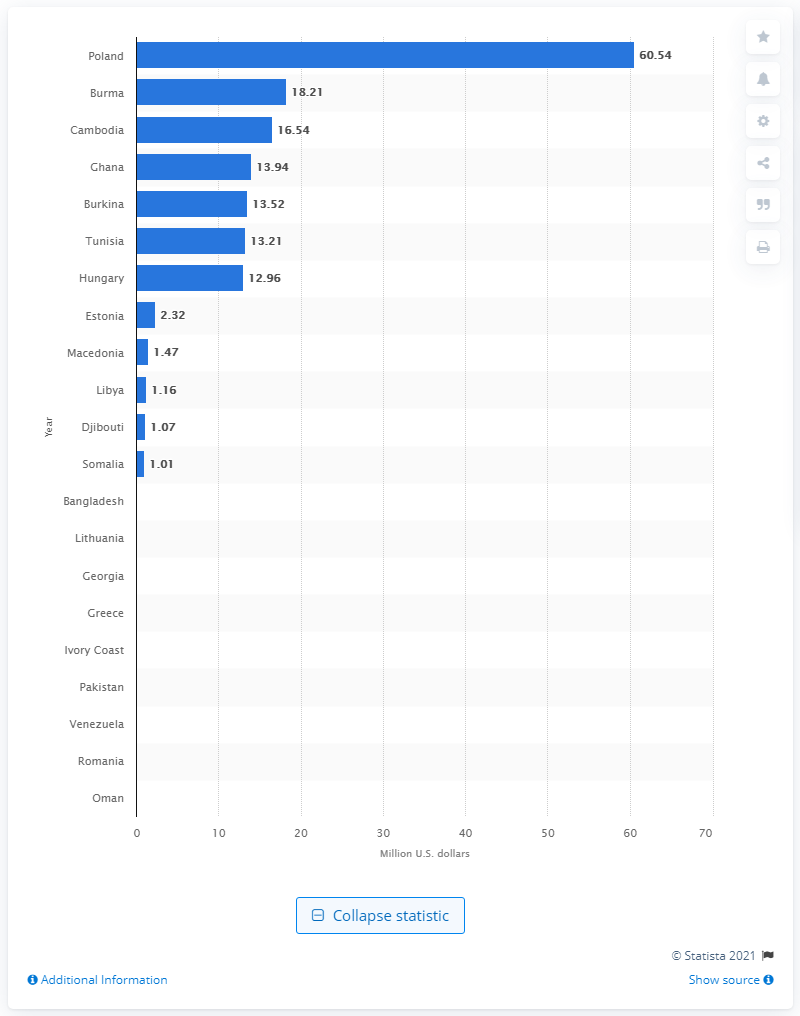Identify some key points in this picture. In 2002, the fastest growing U.S. textile and apparel market was Poland. In 2002, Poland's value was estimated to be 60.54 dollars. 